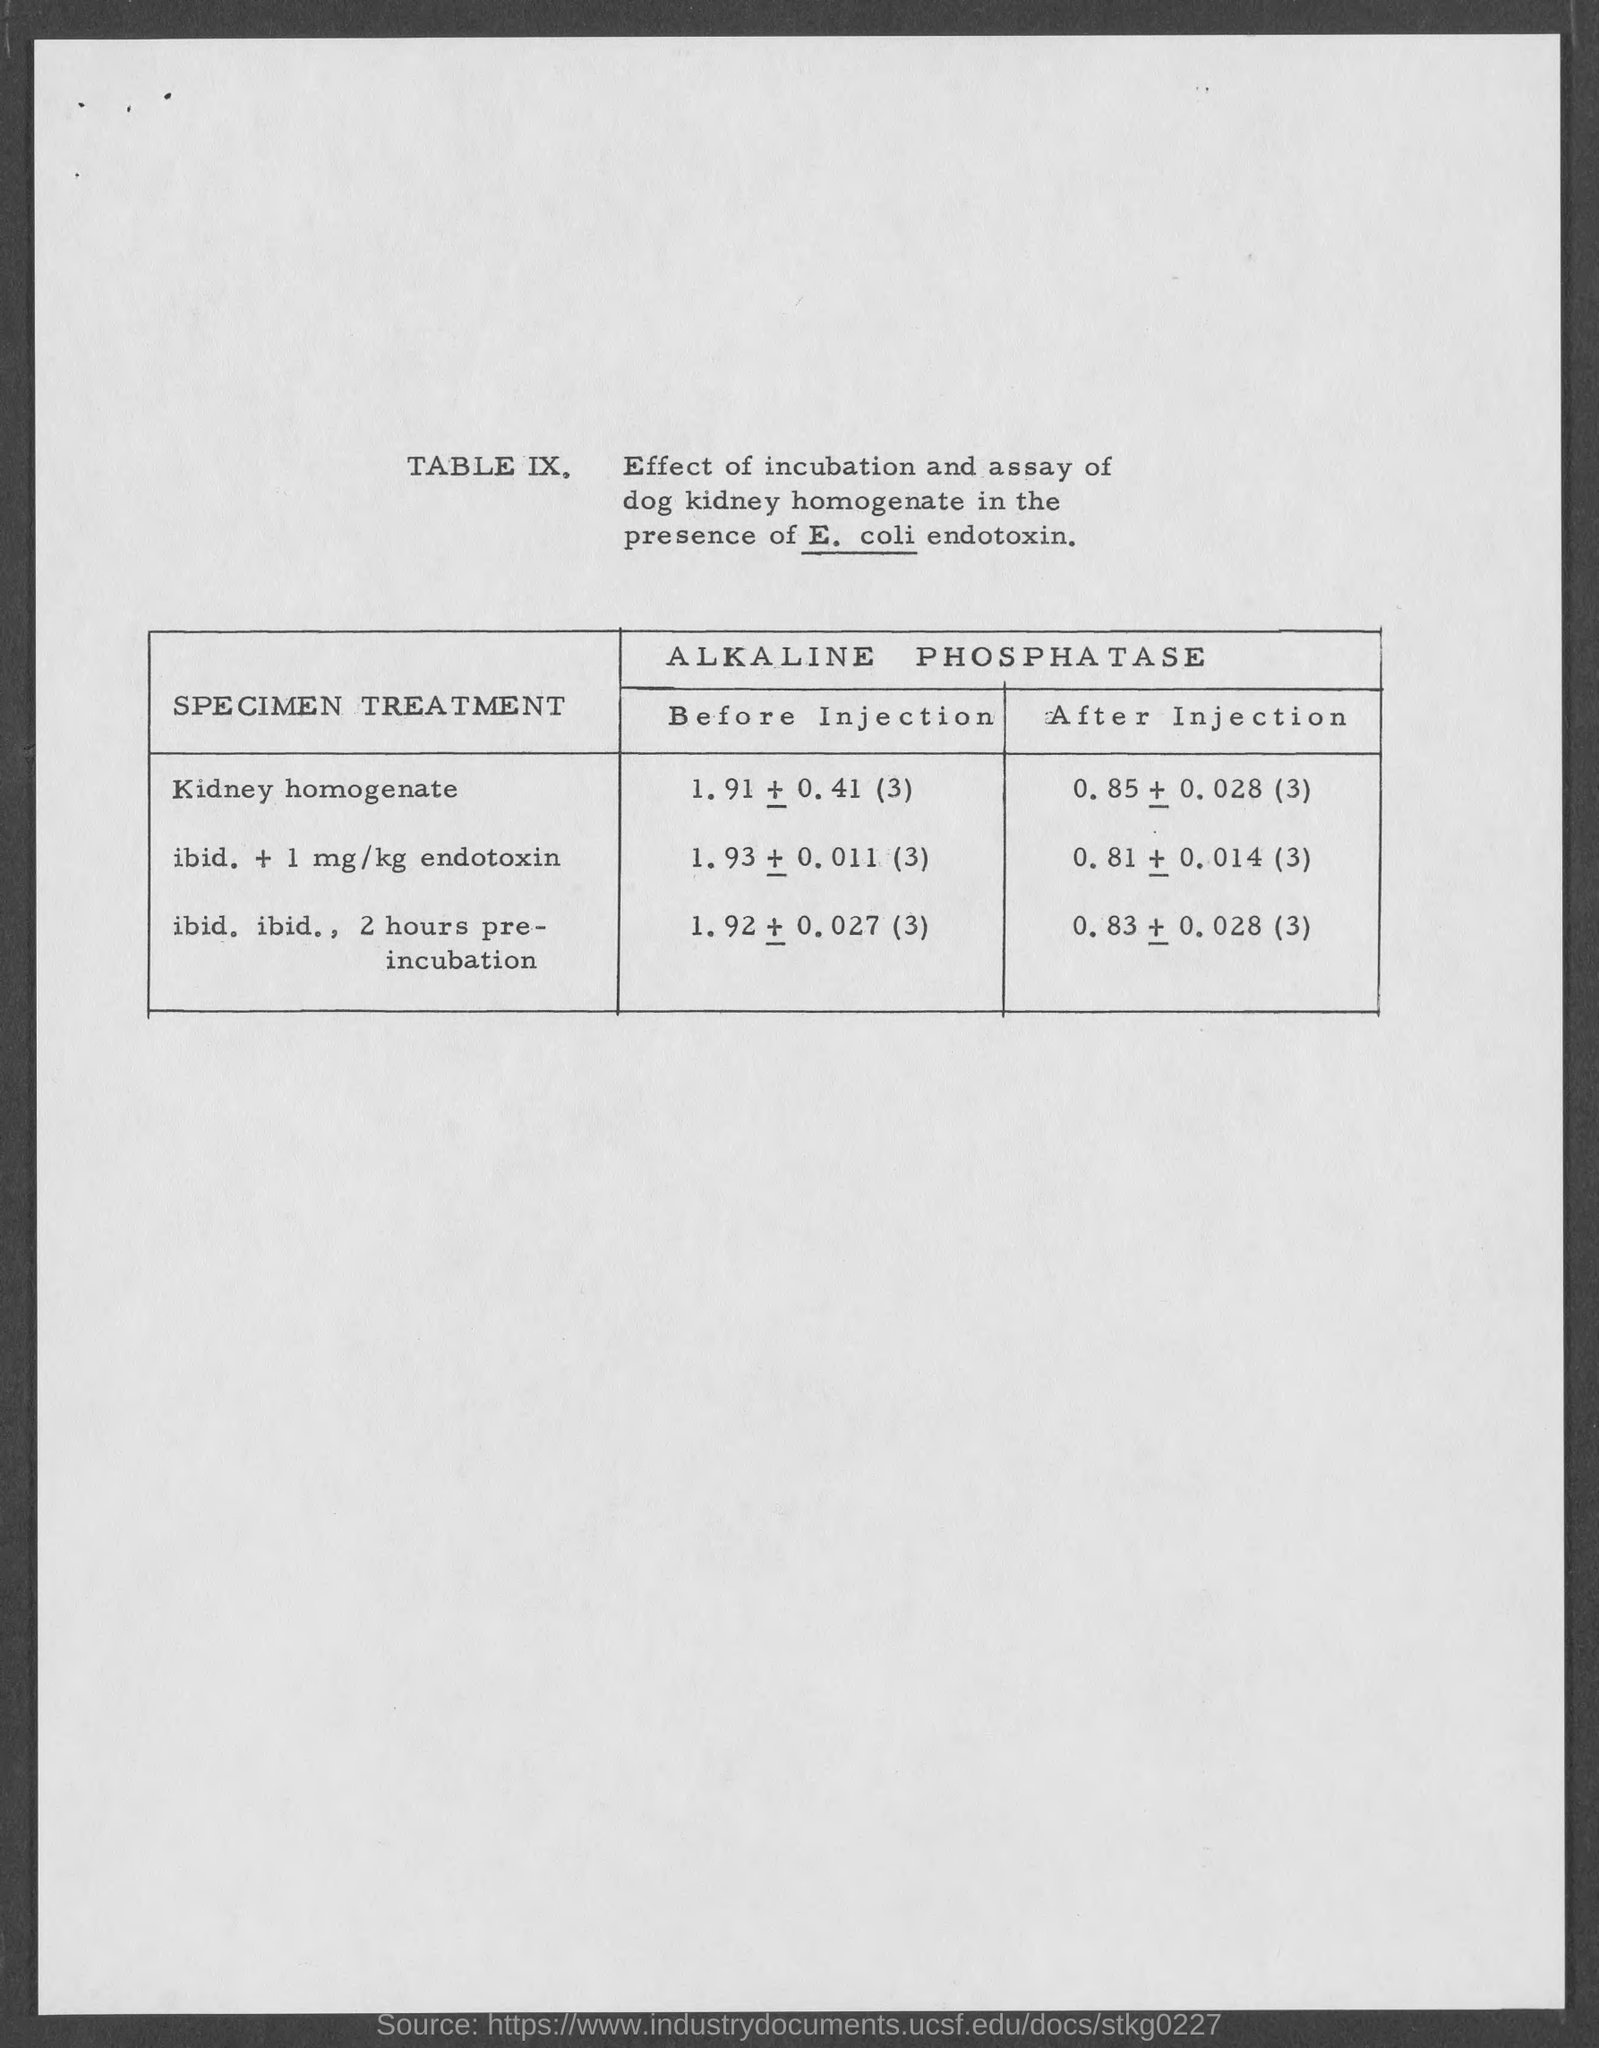What is the heading of the Table ?
Your answer should be compact. Effect of incubation and assay of dog kidney homogenate in the presence of E. coli endotoxin. What is the first column heading of the table?
Make the answer very short. SPECIMEN TREATMENT. What is the first specimen treatment ?
Give a very brief answer. Kidney homogenate. 